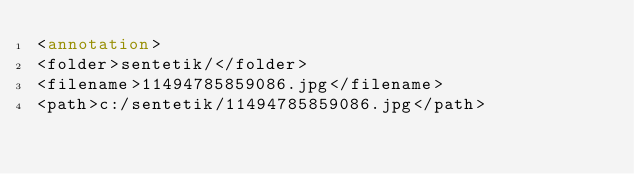<code> <loc_0><loc_0><loc_500><loc_500><_XML_><annotation>
<folder>sentetik/</folder>
<filename>11494785859086.jpg</filename>
<path>c:/sentetik/11494785859086.jpg</path></code> 